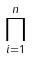Convert formula to latex. <formula><loc_0><loc_0><loc_500><loc_500>\prod _ { i = 1 } ^ { n }</formula> 